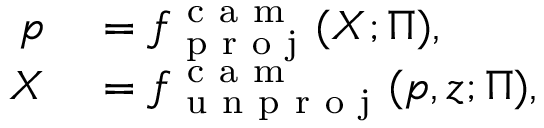<formula> <loc_0><loc_0><loc_500><loc_500>\begin{array} { r l } { p } & = f _ { p r o j } ^ { c a m } ( X ; \Pi ) , } \\ { X } & = f _ { u n p r o j } ^ { c a m } ( p , z ; \Pi ) , } \end{array}</formula> 